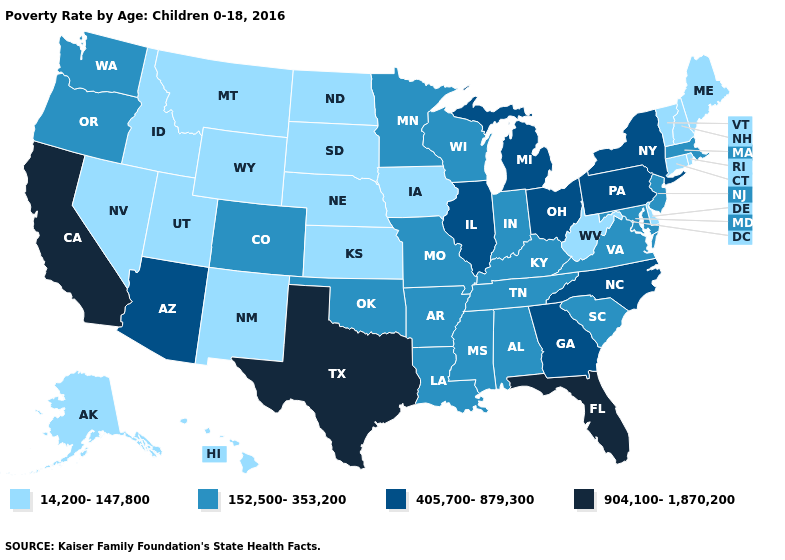What is the highest value in the USA?
Answer briefly. 904,100-1,870,200. Among the states that border Oregon , which have the highest value?
Concise answer only. California. Name the states that have a value in the range 152,500-353,200?
Keep it brief. Alabama, Arkansas, Colorado, Indiana, Kentucky, Louisiana, Maryland, Massachusetts, Minnesota, Mississippi, Missouri, New Jersey, Oklahoma, Oregon, South Carolina, Tennessee, Virginia, Washington, Wisconsin. Among the states that border Illinois , which have the lowest value?
Short answer required. Iowa. Among the states that border Ohio , which have the lowest value?
Answer briefly. West Virginia. Name the states that have a value in the range 14,200-147,800?
Concise answer only. Alaska, Connecticut, Delaware, Hawaii, Idaho, Iowa, Kansas, Maine, Montana, Nebraska, Nevada, New Hampshire, New Mexico, North Dakota, Rhode Island, South Dakota, Utah, Vermont, West Virginia, Wyoming. Does Connecticut have a higher value than Kentucky?
Concise answer only. No. What is the lowest value in the West?
Answer briefly. 14,200-147,800. Does Florida have a lower value than Nevada?
Give a very brief answer. No. What is the value of New Hampshire?
Write a very short answer. 14,200-147,800. What is the value of Tennessee?
Answer briefly. 152,500-353,200. Does Alaska have the highest value in the USA?
Concise answer only. No. What is the value of South Dakota?
Short answer required. 14,200-147,800. What is the value of Texas?
Be succinct. 904,100-1,870,200. Does Texas have the highest value in the USA?
Concise answer only. Yes. 